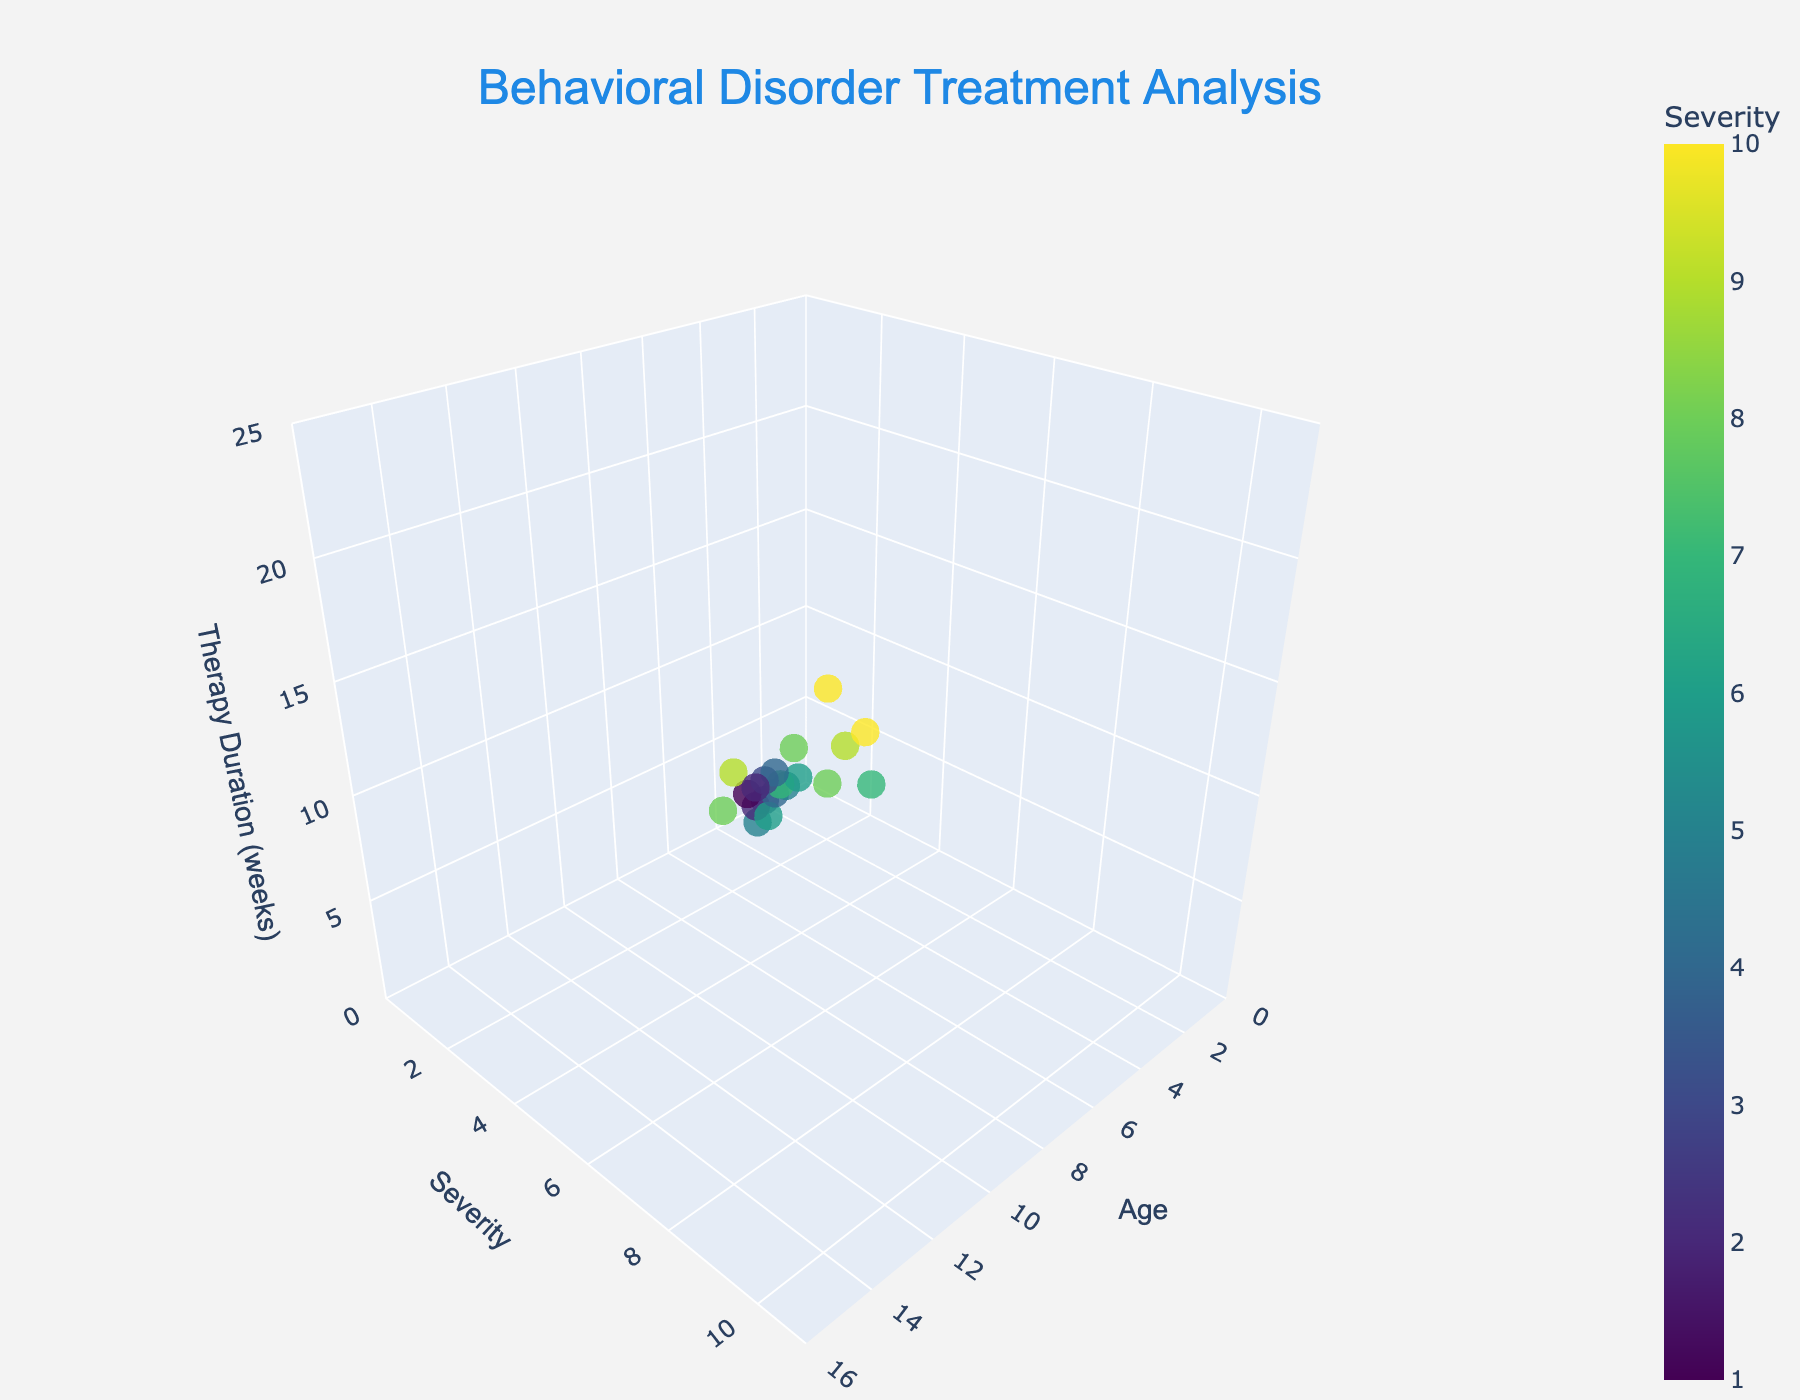What is the title of the 3D scatter plot? The title can be found at the top center of the plot and usually summarizes the main theme of the data visualization. In this case, it reads 'Behavioral Disorder Treatment Analysis'.
Answer: Behavioral Disorder Treatment Analysis How many data points are there in the scatter plot? You can count the number of colored markers on the plot. Each marker represents one data point. By counting, you will find there are 20 data points.
Answer: 20 What are the ranges for the Age, Severity, and Therapy Duration axes? The ranges are specified on each axis. For the Age axis, it ranges from 0 to 16. For the Severity axis, it ranges from 0 to 11. For the Therapy Duration axis, it ranges from 0 to 25.
Answer: Age: 0-16, Severity: 0-11, Therapy Duration: 0-25 Which therapy duration is associated with the highest behavioral disorder severity? The data point with the highest severity value will indicate the Therapy Duration for the most severe behavioral disorder case. The data point with Severity 10 is associated with a Therapy Duration of 20 and 22 weeks.
Answer: 20 and 22 weeks What is the average Therapy Duration for children aged 10? Find the data points where Age is 10, then calculate the average of the Therapy Durations for those points. The Age 10 data point has a Therapy Duration of 11. Thus, the average Therapy Duration is 11 weeks.
Answer: 11 weeks What is the color gradient used to represent the Severity values, and which color represents the highest severity? The colorscale 'Viridis' is used, where lower severity values are represented by darker shades and higher severity by lighter shades. Yellowish colors generally represent the highest severity values.
Answer: Yellow Compare the therapy duration for a child aged 5 with a severity of 2 to a child aged 5 with a severity of 2. Both points have Age 5 and Severity 2. Their Therapy Durations are 4 and 5 weeks, respectively.
Answer: 4 and 5 weeks What is the relationship between age and average behavioral disorder severity? By observing the plot and trends, you can determine if severity tends to increase or decrease with age. There is no clear trend as severities remain generally distributed across ages.
Answer: No clear trend Which data point represents the oldest child who has a behavioral disorder severity over 7, and what is their therapy duration? Isolate data points where Severity is more than 7, then identify the point with the highest Age value, which is Age 15 and Severity 9. The Therapy Duration for this point is 19 weeks.
Answer: 19 weeks Is there a specific age group that tends to have longer therapy durations and high severity levels? Look for clustering of data points with high severity and therapy duration values across ages. Ages 12-14 show multiple points with long durations (16-22 weeks) and high severity levels (8-10).
Answer: Ages 12-14 